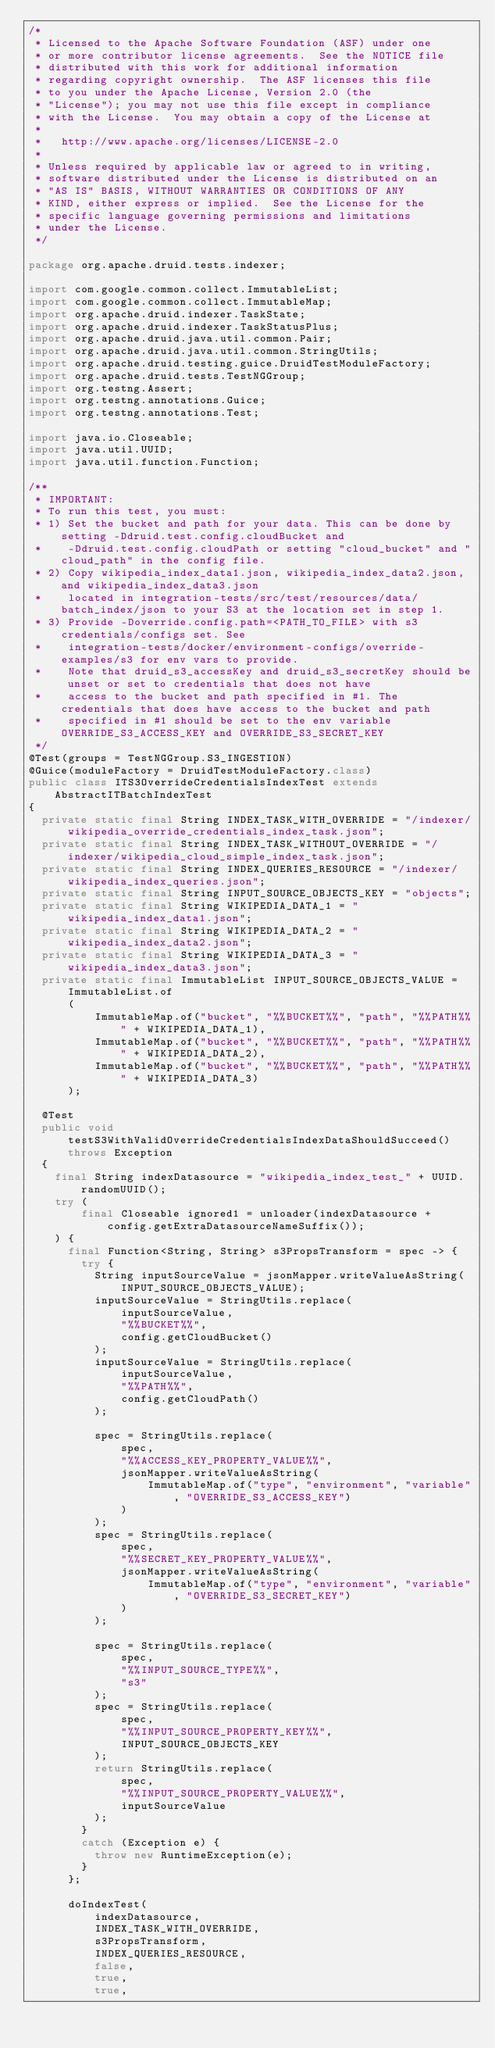<code> <loc_0><loc_0><loc_500><loc_500><_Java_>/*
 * Licensed to the Apache Software Foundation (ASF) under one
 * or more contributor license agreements.  See the NOTICE file
 * distributed with this work for additional information
 * regarding copyright ownership.  The ASF licenses this file
 * to you under the Apache License, Version 2.0 (the
 * "License"); you may not use this file except in compliance
 * with the License.  You may obtain a copy of the License at
 *
 *   http://www.apache.org/licenses/LICENSE-2.0
 *
 * Unless required by applicable law or agreed to in writing,
 * software distributed under the License is distributed on an
 * "AS IS" BASIS, WITHOUT WARRANTIES OR CONDITIONS OF ANY
 * KIND, either express or implied.  See the License for the
 * specific language governing permissions and limitations
 * under the License.
 */

package org.apache.druid.tests.indexer;

import com.google.common.collect.ImmutableList;
import com.google.common.collect.ImmutableMap;
import org.apache.druid.indexer.TaskState;
import org.apache.druid.indexer.TaskStatusPlus;
import org.apache.druid.java.util.common.Pair;
import org.apache.druid.java.util.common.StringUtils;
import org.apache.druid.testing.guice.DruidTestModuleFactory;
import org.apache.druid.tests.TestNGGroup;
import org.testng.Assert;
import org.testng.annotations.Guice;
import org.testng.annotations.Test;

import java.io.Closeable;
import java.util.UUID;
import java.util.function.Function;

/**
 * IMPORTANT:
 * To run this test, you must:
 * 1) Set the bucket and path for your data. This can be done by setting -Ddruid.test.config.cloudBucket and
 *    -Ddruid.test.config.cloudPath or setting "cloud_bucket" and "cloud_path" in the config file.
 * 2) Copy wikipedia_index_data1.json, wikipedia_index_data2.json, and wikipedia_index_data3.json
 *    located in integration-tests/src/test/resources/data/batch_index/json to your S3 at the location set in step 1.
 * 3) Provide -Doverride.config.path=<PATH_TO_FILE> with s3 credentials/configs set. See
 *    integration-tests/docker/environment-configs/override-examples/s3 for env vars to provide.
 *    Note that druid_s3_accessKey and druid_s3_secretKey should be unset or set to credentials that does not have
 *    access to the bucket and path specified in #1. The credentials that does have access to the bucket and path
 *    specified in #1 should be set to the env variable OVERRIDE_S3_ACCESS_KEY and OVERRIDE_S3_SECRET_KEY
 */
@Test(groups = TestNGGroup.S3_INGESTION)
@Guice(moduleFactory = DruidTestModuleFactory.class)
public class ITS3OverrideCredentialsIndexTest extends AbstractITBatchIndexTest
{
  private static final String INDEX_TASK_WITH_OVERRIDE = "/indexer/wikipedia_override_credentials_index_task.json";
  private static final String INDEX_TASK_WITHOUT_OVERRIDE = "/indexer/wikipedia_cloud_simple_index_task.json";
  private static final String INDEX_QUERIES_RESOURCE = "/indexer/wikipedia_index_queries.json";
  private static final String INPUT_SOURCE_OBJECTS_KEY = "objects";
  private static final String WIKIPEDIA_DATA_1 = "wikipedia_index_data1.json";
  private static final String WIKIPEDIA_DATA_2 = "wikipedia_index_data2.json";
  private static final String WIKIPEDIA_DATA_3 = "wikipedia_index_data3.json";
  private static final ImmutableList INPUT_SOURCE_OBJECTS_VALUE = ImmutableList.of
      (
          ImmutableMap.of("bucket", "%%BUCKET%%", "path", "%%PATH%%" + WIKIPEDIA_DATA_1),
          ImmutableMap.of("bucket", "%%BUCKET%%", "path", "%%PATH%%" + WIKIPEDIA_DATA_2),
          ImmutableMap.of("bucket", "%%BUCKET%%", "path", "%%PATH%%" + WIKIPEDIA_DATA_3)
      );

  @Test
  public void testS3WithValidOverrideCredentialsIndexDataShouldSucceed() throws Exception
  {
    final String indexDatasource = "wikipedia_index_test_" + UUID.randomUUID();
    try (
        final Closeable ignored1 = unloader(indexDatasource + config.getExtraDatasourceNameSuffix());
    ) {
      final Function<String, String> s3PropsTransform = spec -> {
        try {
          String inputSourceValue = jsonMapper.writeValueAsString(INPUT_SOURCE_OBJECTS_VALUE);
          inputSourceValue = StringUtils.replace(
              inputSourceValue,
              "%%BUCKET%%",
              config.getCloudBucket()
          );
          inputSourceValue = StringUtils.replace(
              inputSourceValue,
              "%%PATH%%",
              config.getCloudPath()
          );

          spec = StringUtils.replace(
              spec,
              "%%ACCESS_KEY_PROPERTY_VALUE%%",
              jsonMapper.writeValueAsString(
                  ImmutableMap.of("type", "environment", "variable", "OVERRIDE_S3_ACCESS_KEY")
              )
          );
          spec = StringUtils.replace(
              spec,
              "%%SECRET_KEY_PROPERTY_VALUE%%",
              jsonMapper.writeValueAsString(
                  ImmutableMap.of("type", "environment", "variable", "OVERRIDE_S3_SECRET_KEY")
              )
          );

          spec = StringUtils.replace(
              spec,
              "%%INPUT_SOURCE_TYPE%%",
              "s3"
          );
          spec = StringUtils.replace(
              spec,
              "%%INPUT_SOURCE_PROPERTY_KEY%%",
              INPUT_SOURCE_OBJECTS_KEY
          );
          return StringUtils.replace(
              spec,
              "%%INPUT_SOURCE_PROPERTY_VALUE%%",
              inputSourceValue
          );
        }
        catch (Exception e) {
          throw new RuntimeException(e);
        }
      };

      doIndexTest(
          indexDatasource,
          INDEX_TASK_WITH_OVERRIDE,
          s3PropsTransform,
          INDEX_QUERIES_RESOURCE,
          false,
          true,
          true,</code> 